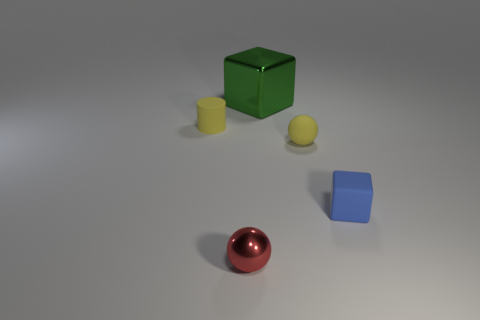What is the material of the ball that is the same color as the matte cylinder?
Offer a terse response. Rubber. What number of big objects are on the left side of the small yellow cylinder?
Your answer should be very brief. 0. Are the small block and the yellow thing in front of the yellow rubber cylinder made of the same material?
Your answer should be very brief. Yes. Are there any other things that have the same shape as the small shiny thing?
Ensure brevity in your answer.  Yes. Do the large thing and the red thing have the same material?
Keep it short and to the point. Yes. Is there a matte cylinder in front of the small yellow thing to the right of the tiny yellow cylinder?
Offer a terse response. No. How many small things are right of the green block and left of the blue matte cube?
Provide a succinct answer. 1. What shape is the metallic thing that is behind the tiny metallic sphere?
Ensure brevity in your answer.  Cube. What number of purple metallic cubes are the same size as the matte cylinder?
Your response must be concise. 0. Do the ball on the left side of the rubber sphere and the large object have the same color?
Keep it short and to the point. No. 